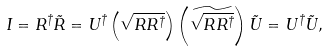Convert formula to latex. <formula><loc_0><loc_0><loc_500><loc_500>I = R ^ { \dagger } \tilde { R } = U ^ { \dagger } \left ( \sqrt { R R ^ { \dagger } } \right ) \left ( \widetilde { \sqrt { R R ^ { \dagger } } } \right ) \tilde { U } = U ^ { \dagger } \tilde { U } ,</formula> 